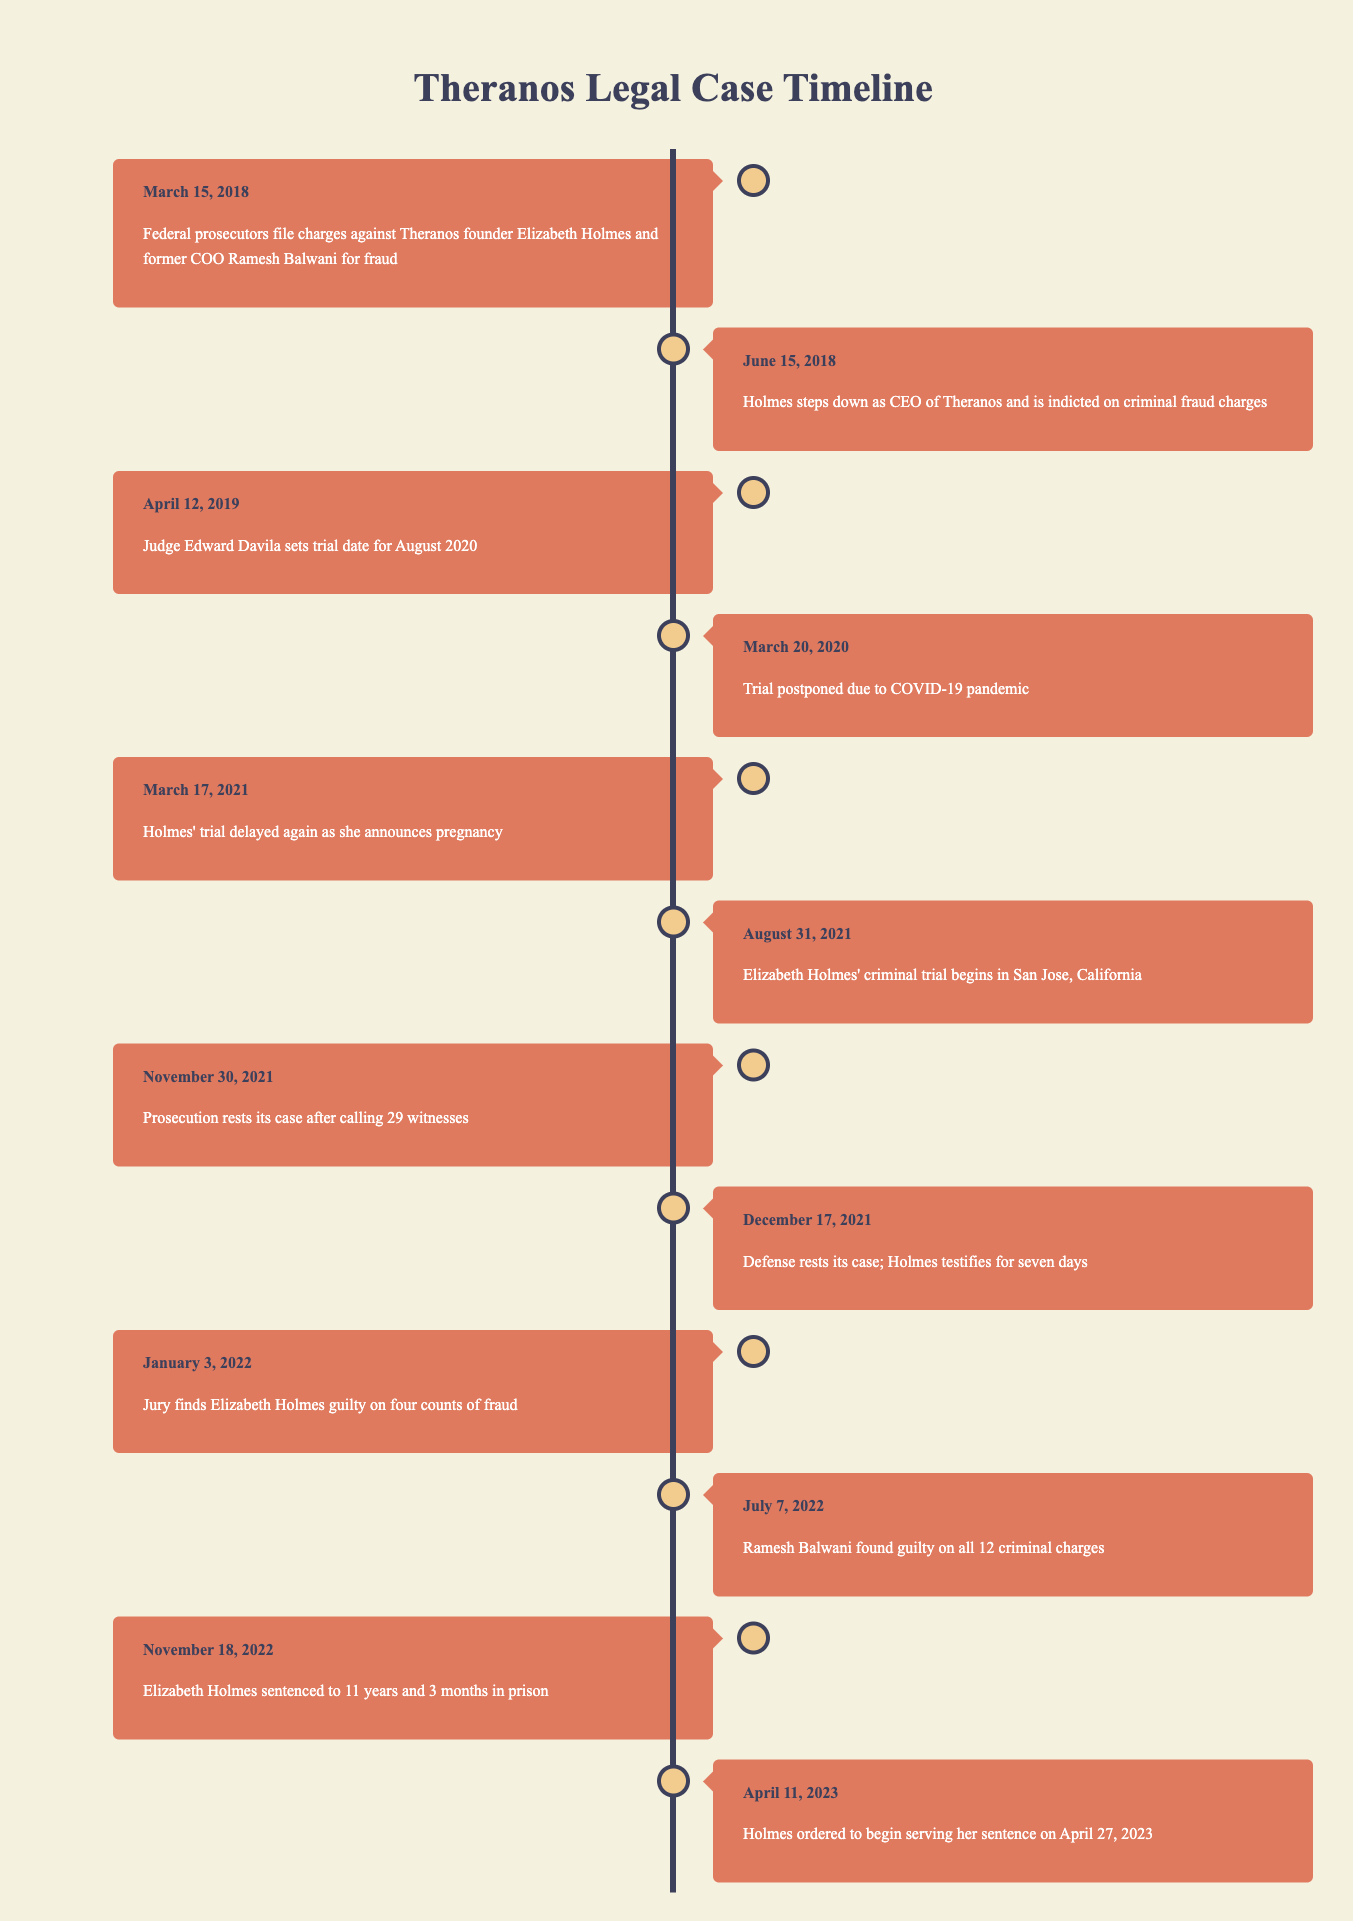What event occurred on March 15, 2018? According to the timeline, on March 15, 2018, federal prosecutors filed charges against Elizabeth Holmes and Ramesh Balwani for fraud.
Answer: Federal prosecutors filed charges against Theranos founder Elizabeth Holmes and former COO Ramesh Balwani for fraud How many witnesses did the prosecution call before resting its case? The timeline specifies that the prosecution called 29 witnesses before it rested its case on November 30, 2021.
Answer: 29 witnesses What is the duration of Elizabeth Holmes's prison sentence? The timeline indicates that Elizabeth Holmes was sentenced to 11 years and 3 months in prison on November 18, 2022. Therefore, the total duration is 11 years and 3 months.
Answer: 11 years and 3 months Was Elizabeth Holmes found guilty on all counts? The timeline shows that the jury found Elizabeth Holmes guilty on four counts of fraud on January 3, 2022. This means she was not found guilty on all charges since there were only four counts she was convicted of.
Answer: No How much time elapsed between the filing of charges and the start of Holmes' trial? The charges were filed on March 15, 2018, and Holmes' trial began on August 31, 2021. The elapsed time is calculated as follows: from March 15, 2018, to March 15, 2021, is 3 years, and from March 15 to August 31 is an additional 5 months and 16 days. Therefore, the total elapsed time is 3 years, 5 months, and 16 days.
Answer: 3 years, 5 months, and 16 days 